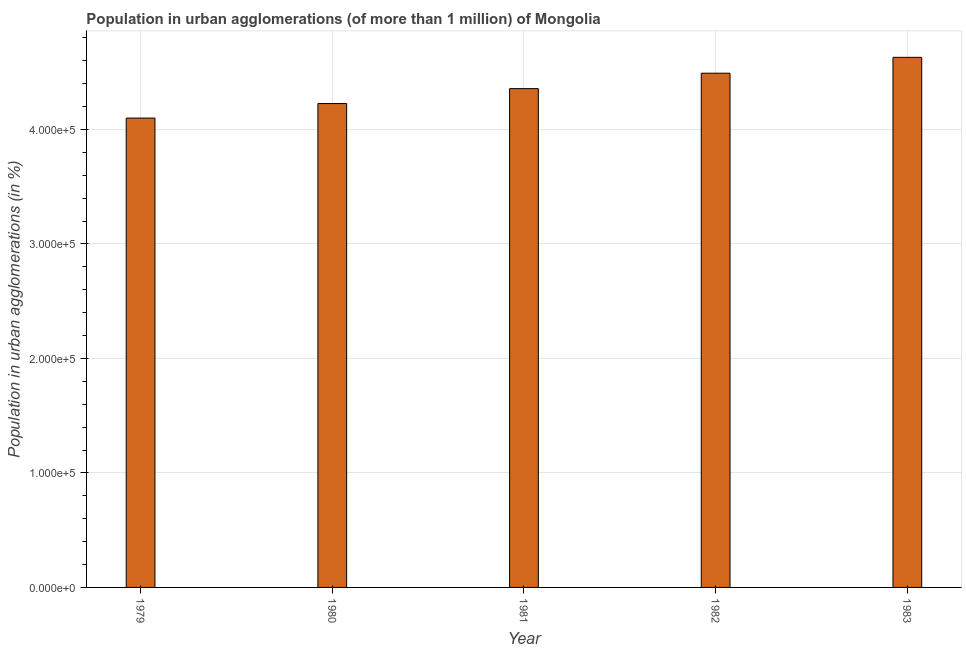What is the title of the graph?
Make the answer very short. Population in urban agglomerations (of more than 1 million) of Mongolia. What is the label or title of the X-axis?
Provide a succinct answer. Year. What is the label or title of the Y-axis?
Give a very brief answer. Population in urban agglomerations (in %). What is the population in urban agglomerations in 1980?
Give a very brief answer. 4.23e+05. Across all years, what is the maximum population in urban agglomerations?
Offer a terse response. 4.63e+05. Across all years, what is the minimum population in urban agglomerations?
Offer a terse response. 4.10e+05. In which year was the population in urban agglomerations maximum?
Provide a short and direct response. 1983. In which year was the population in urban agglomerations minimum?
Provide a short and direct response. 1979. What is the sum of the population in urban agglomerations?
Your answer should be compact. 2.18e+06. What is the difference between the population in urban agglomerations in 1979 and 1983?
Ensure brevity in your answer.  -5.31e+04. What is the average population in urban agglomerations per year?
Offer a terse response. 4.36e+05. What is the median population in urban agglomerations?
Give a very brief answer. 4.36e+05. In how many years, is the population in urban agglomerations greater than 400000 %?
Provide a succinct answer. 5. What is the ratio of the population in urban agglomerations in 1980 to that in 1981?
Provide a succinct answer. 0.97. What is the difference between the highest and the second highest population in urban agglomerations?
Make the answer very short. 1.39e+04. Is the sum of the population in urban agglomerations in 1979 and 1983 greater than the maximum population in urban agglomerations across all years?
Provide a succinct answer. Yes. What is the difference between the highest and the lowest population in urban agglomerations?
Your response must be concise. 5.31e+04. How many bars are there?
Your answer should be very brief. 5. What is the difference between two consecutive major ticks on the Y-axis?
Keep it short and to the point. 1.00e+05. Are the values on the major ticks of Y-axis written in scientific E-notation?
Your answer should be very brief. Yes. What is the Population in urban agglomerations (in %) of 1979?
Your answer should be very brief. 4.10e+05. What is the Population in urban agglomerations (in %) of 1980?
Your response must be concise. 4.23e+05. What is the Population in urban agglomerations (in %) in 1981?
Provide a short and direct response. 4.36e+05. What is the Population in urban agglomerations (in %) in 1982?
Give a very brief answer. 4.49e+05. What is the Population in urban agglomerations (in %) in 1983?
Your answer should be compact. 4.63e+05. What is the difference between the Population in urban agglomerations (in %) in 1979 and 1980?
Ensure brevity in your answer.  -1.27e+04. What is the difference between the Population in urban agglomerations (in %) in 1979 and 1981?
Your response must be concise. -2.57e+04. What is the difference between the Population in urban agglomerations (in %) in 1979 and 1982?
Keep it short and to the point. -3.92e+04. What is the difference between the Population in urban agglomerations (in %) in 1979 and 1983?
Provide a short and direct response. -5.31e+04. What is the difference between the Population in urban agglomerations (in %) in 1980 and 1981?
Provide a succinct answer. -1.30e+04. What is the difference between the Population in urban agglomerations (in %) in 1980 and 1982?
Offer a terse response. -2.65e+04. What is the difference between the Population in urban agglomerations (in %) in 1980 and 1983?
Give a very brief answer. -4.04e+04. What is the difference between the Population in urban agglomerations (in %) in 1981 and 1982?
Give a very brief answer. -1.35e+04. What is the difference between the Population in urban agglomerations (in %) in 1981 and 1983?
Your answer should be compact. -2.73e+04. What is the difference between the Population in urban agglomerations (in %) in 1982 and 1983?
Provide a succinct answer. -1.39e+04. What is the ratio of the Population in urban agglomerations (in %) in 1979 to that in 1980?
Provide a short and direct response. 0.97. What is the ratio of the Population in urban agglomerations (in %) in 1979 to that in 1981?
Give a very brief answer. 0.94. What is the ratio of the Population in urban agglomerations (in %) in 1979 to that in 1982?
Keep it short and to the point. 0.91. What is the ratio of the Population in urban agglomerations (in %) in 1979 to that in 1983?
Keep it short and to the point. 0.89. What is the ratio of the Population in urban agglomerations (in %) in 1980 to that in 1981?
Keep it short and to the point. 0.97. What is the ratio of the Population in urban agglomerations (in %) in 1980 to that in 1982?
Provide a succinct answer. 0.94. What is the ratio of the Population in urban agglomerations (in %) in 1980 to that in 1983?
Ensure brevity in your answer.  0.91. What is the ratio of the Population in urban agglomerations (in %) in 1981 to that in 1982?
Ensure brevity in your answer.  0.97. What is the ratio of the Population in urban agglomerations (in %) in 1981 to that in 1983?
Offer a terse response. 0.94. What is the ratio of the Population in urban agglomerations (in %) in 1982 to that in 1983?
Offer a very short reply. 0.97. 